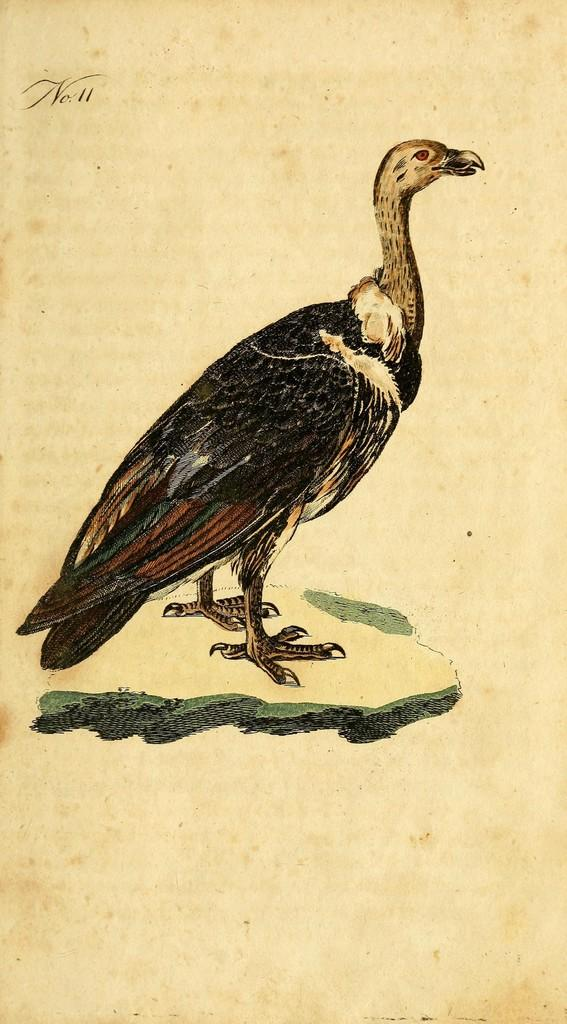What is the medium of the image? The image appears to be a drawing. What is the main subject of the drawing? There is a bird in the center of the drawing. What color is the background of the drawing? The background of the drawing is white. Where is the text located in the drawing? The text is at the top of the drawing. Can you tell me how many porters are carrying the baby in the drawing? There are no porters or babies present in the drawing; it features a bird and text. What direction does the bird turn in the drawing? The bird is not turning in any direction in the drawing; it is stationary in the center. 